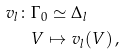Convert formula to latex. <formula><loc_0><loc_0><loc_500><loc_500>v _ { l } \colon & \Gamma _ { 0 } \simeq \Delta _ { l } \\ & V \mapsto v _ { l } ( V ) \, ,</formula> 